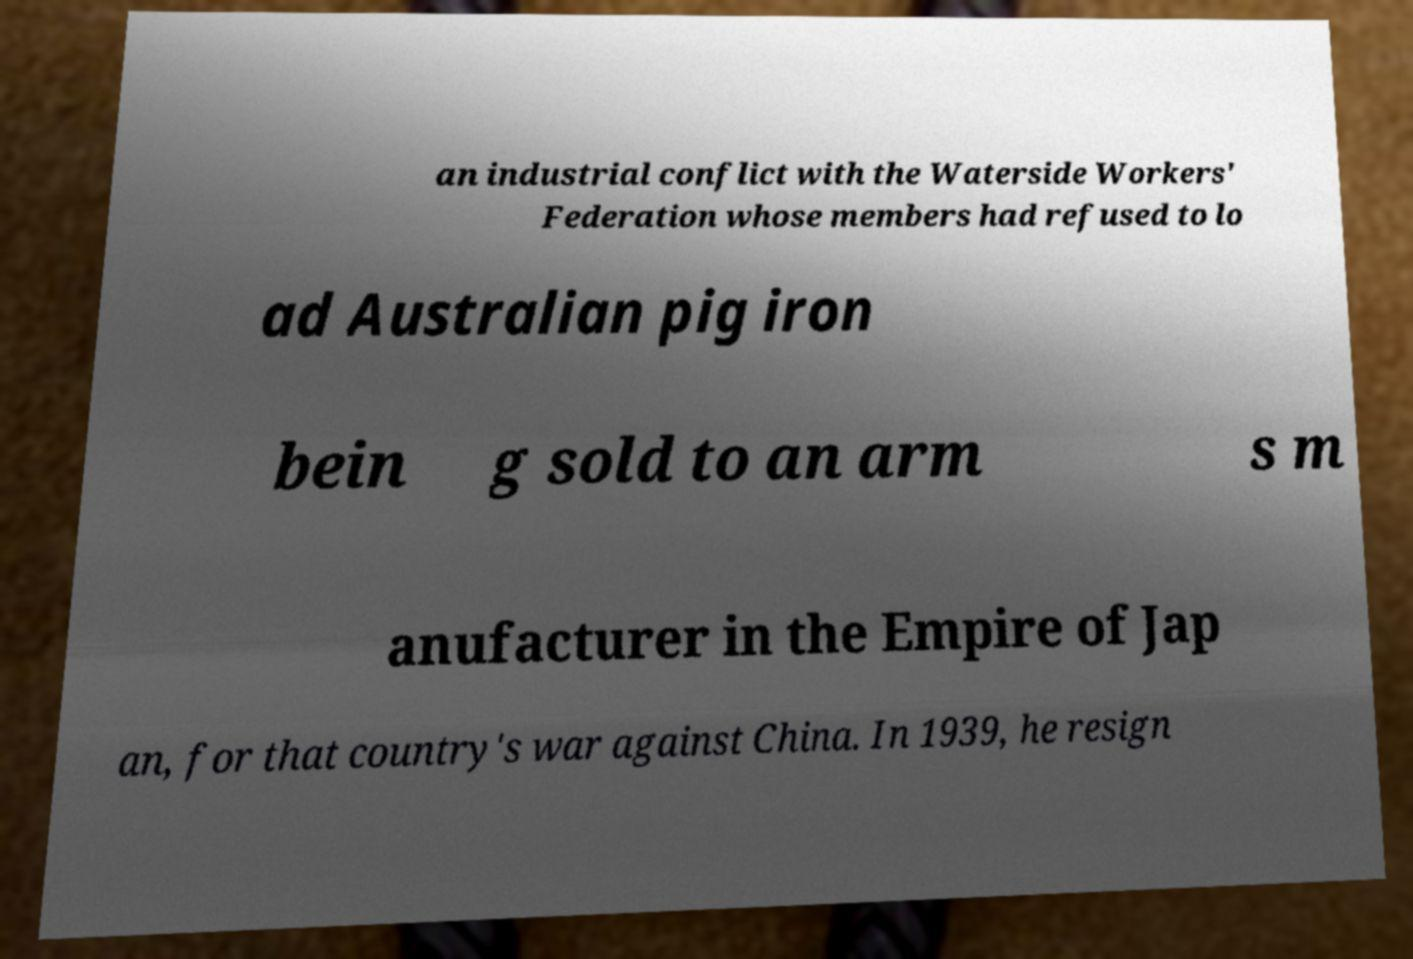Can you accurately transcribe the text from the provided image for me? an industrial conflict with the Waterside Workers' Federation whose members had refused to lo ad Australian pig iron bein g sold to an arm s m anufacturer in the Empire of Jap an, for that country's war against China. In 1939, he resign 